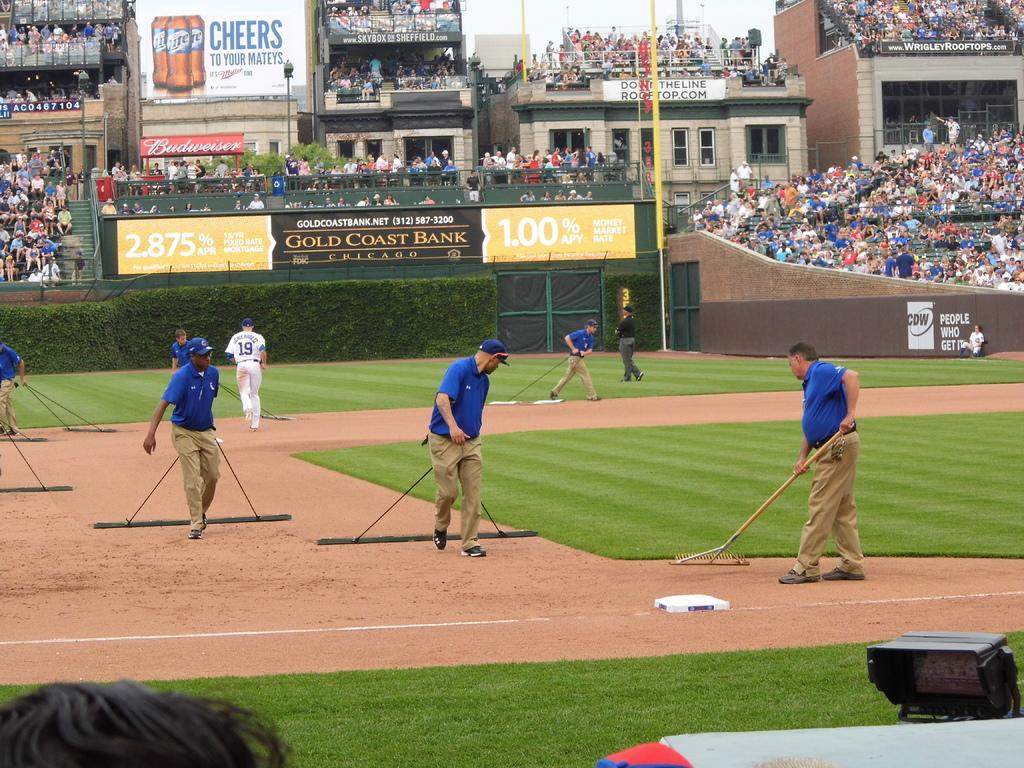<image>
Summarize the visual content of the image. Men raking the baseball field to get ready for a game to be played, text on the wall saying CDW People who get it. 